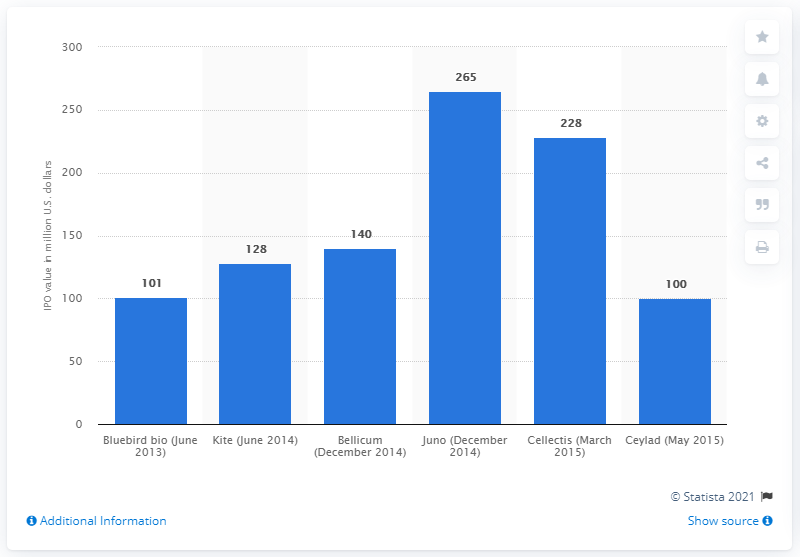Identify some key points in this picture. Kite Pharma's initial public offering (IPO) value in June 2014 was $128 million. 